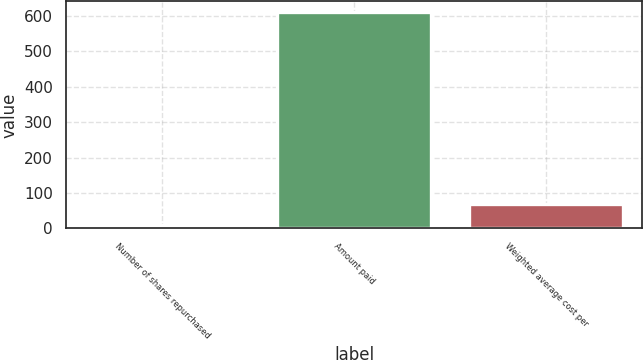Convert chart to OTSL. <chart><loc_0><loc_0><loc_500><loc_500><bar_chart><fcel>Number of shares repurchased<fcel>Amount paid<fcel>Weighted average cost per<nl><fcel>9.6<fcel>610.7<fcel>69.71<nl></chart> 